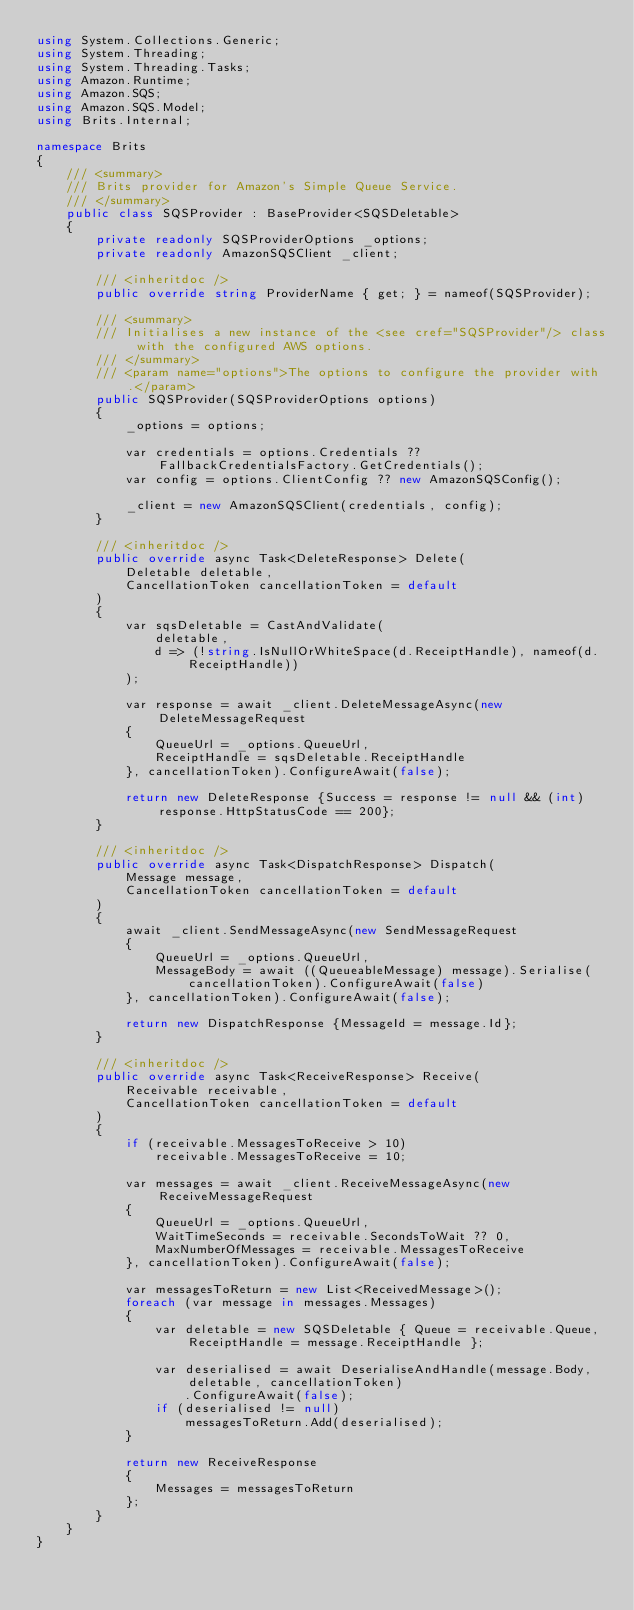<code> <loc_0><loc_0><loc_500><loc_500><_C#_>using System.Collections.Generic;
using System.Threading;
using System.Threading.Tasks;
using Amazon.Runtime;
using Amazon.SQS;
using Amazon.SQS.Model;
using Brits.Internal;

namespace Brits
{
    /// <summary>
    /// Brits provider for Amazon's Simple Queue Service.
    /// </summary>
    public class SQSProvider : BaseProvider<SQSDeletable>
    {
        private readonly SQSProviderOptions _options;
        private readonly AmazonSQSClient _client;

        /// <inheritdoc />
        public override string ProviderName { get; } = nameof(SQSProvider);

        /// <summary>
        /// Initialises a new instance of the <see cref="SQSProvider"/> class with the configured AWS options.
        /// </summary>
        /// <param name="options">The options to configure the provider with.</param>
        public SQSProvider(SQSProviderOptions options)
        {
            _options = options;

            var credentials = options.Credentials ?? FallbackCredentialsFactory.GetCredentials();
            var config = options.ClientConfig ?? new AmazonSQSConfig();

            _client = new AmazonSQSClient(credentials, config);
        }

        /// <inheritdoc />
        public override async Task<DeleteResponse> Delete(
            Deletable deletable,
            CancellationToken cancellationToken = default
        )
        {
            var sqsDeletable = CastAndValidate(
                deletable,
                d => (!string.IsNullOrWhiteSpace(d.ReceiptHandle), nameof(d.ReceiptHandle))
            );
            
            var response = await _client.DeleteMessageAsync(new DeleteMessageRequest
            {
                QueueUrl = _options.QueueUrl,
                ReceiptHandle = sqsDeletable.ReceiptHandle
            }, cancellationToken).ConfigureAwait(false);

            return new DeleteResponse {Success = response != null && (int) response.HttpStatusCode == 200};
        }

        /// <inheritdoc />
        public override async Task<DispatchResponse> Dispatch(
            Message message,
            CancellationToken cancellationToken = default
        )
        {
            await _client.SendMessageAsync(new SendMessageRequest
            {
                QueueUrl = _options.QueueUrl,
                MessageBody = await ((QueueableMessage) message).Serialise(cancellationToken).ConfigureAwait(false)
            }, cancellationToken).ConfigureAwait(false);

            return new DispatchResponse {MessageId = message.Id};
        }

        /// <inheritdoc />
        public override async Task<ReceiveResponse> Receive(
            Receivable receivable,
            CancellationToken cancellationToken = default
        )
        {
            if (receivable.MessagesToReceive > 10)
                receivable.MessagesToReceive = 10;

            var messages = await _client.ReceiveMessageAsync(new ReceiveMessageRequest
            {
                QueueUrl = _options.QueueUrl,
                WaitTimeSeconds = receivable.SecondsToWait ?? 0,
                MaxNumberOfMessages = receivable.MessagesToReceive
            }, cancellationToken).ConfigureAwait(false);

            var messagesToReturn = new List<ReceivedMessage>();
            foreach (var message in messages.Messages)
            {
                var deletable = new SQSDeletable { Queue = receivable.Queue, ReceiptHandle = message.ReceiptHandle };

                var deserialised = await DeserialiseAndHandle(message.Body, deletable, cancellationToken)
                    .ConfigureAwait(false);
                if (deserialised != null)
                    messagesToReturn.Add(deserialised);
            }

            return new ReceiveResponse
            {
                Messages = messagesToReturn
            };
        }
    }
}
</code> 